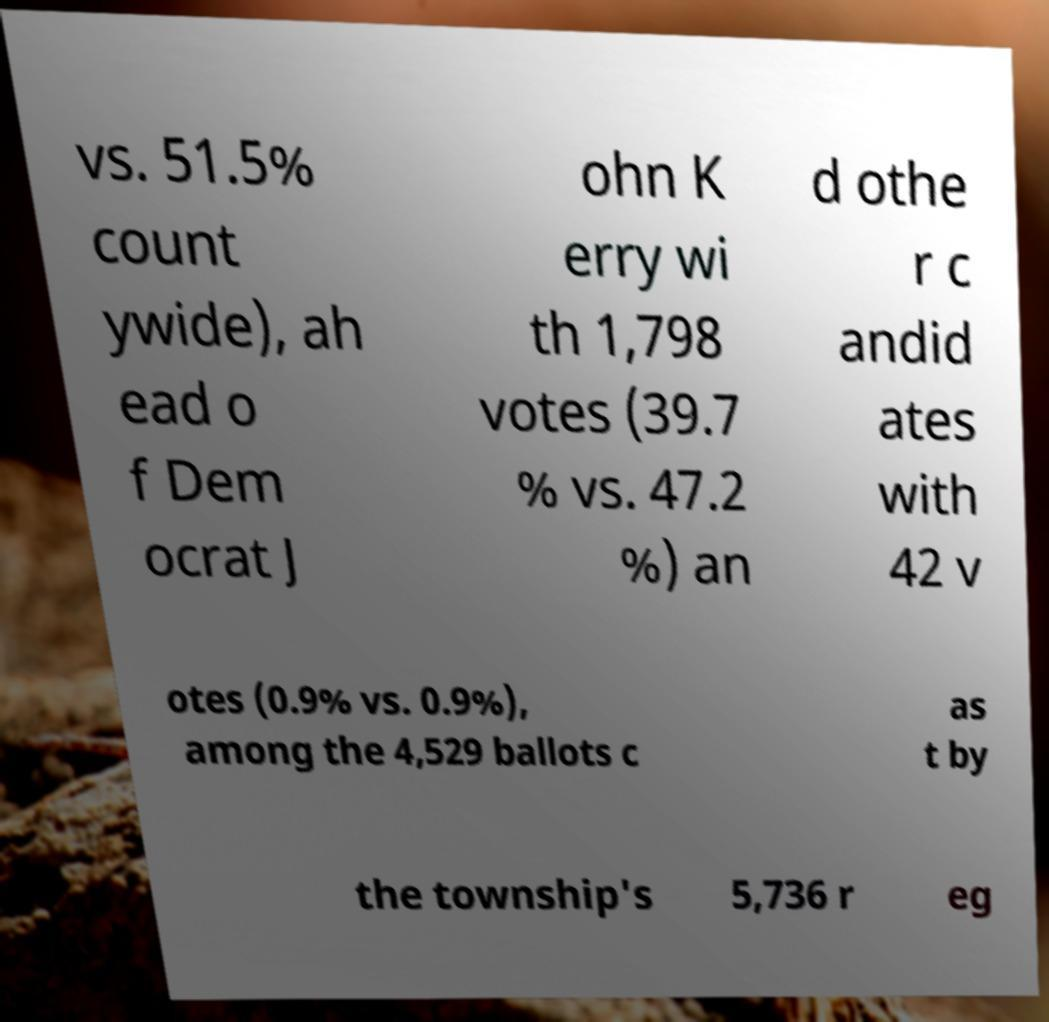There's text embedded in this image that I need extracted. Can you transcribe it verbatim? vs. 51.5% count ywide), ah ead o f Dem ocrat J ohn K erry wi th 1,798 votes (39.7 % vs. 47.2 %) an d othe r c andid ates with 42 v otes (0.9% vs. 0.9%), among the 4,529 ballots c as t by the township's 5,736 r eg 